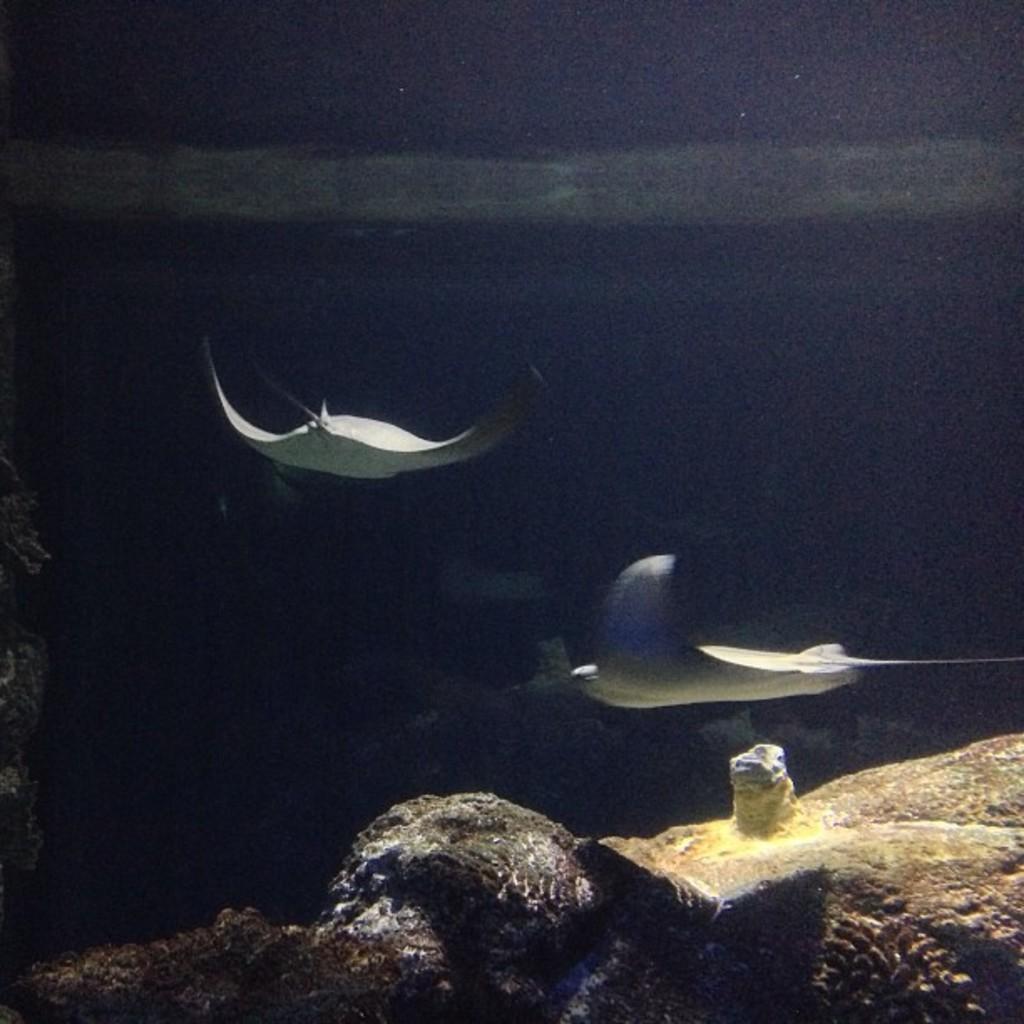Can you describe this image briefly? This image is clicked inside the water. There are stingrays swimming in the water. At the bottom there are rocks. The background is dark. 